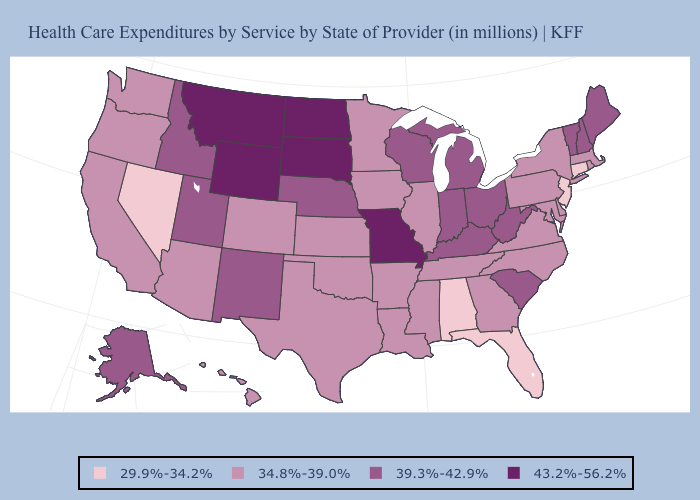What is the lowest value in the MidWest?
Concise answer only. 34.8%-39.0%. What is the highest value in states that border South Carolina?
Give a very brief answer. 34.8%-39.0%. Does the first symbol in the legend represent the smallest category?
Quick response, please. Yes. Does the map have missing data?
Concise answer only. No. Does Alabama have the lowest value in the USA?
Answer briefly. Yes. What is the lowest value in states that border Illinois?
Keep it brief. 34.8%-39.0%. What is the value of Pennsylvania?
Keep it brief. 34.8%-39.0%. Is the legend a continuous bar?
Short answer required. No. What is the highest value in the Northeast ?
Give a very brief answer. 39.3%-42.9%. Is the legend a continuous bar?
Quick response, please. No. Among the states that border Delaware , does Maryland have the lowest value?
Keep it brief. No. Which states have the highest value in the USA?
Short answer required. Missouri, Montana, North Dakota, South Dakota, Wyoming. Does Texas have a lower value than Tennessee?
Write a very short answer. No. How many symbols are there in the legend?
Answer briefly. 4. What is the value of Florida?
Keep it brief. 29.9%-34.2%. 